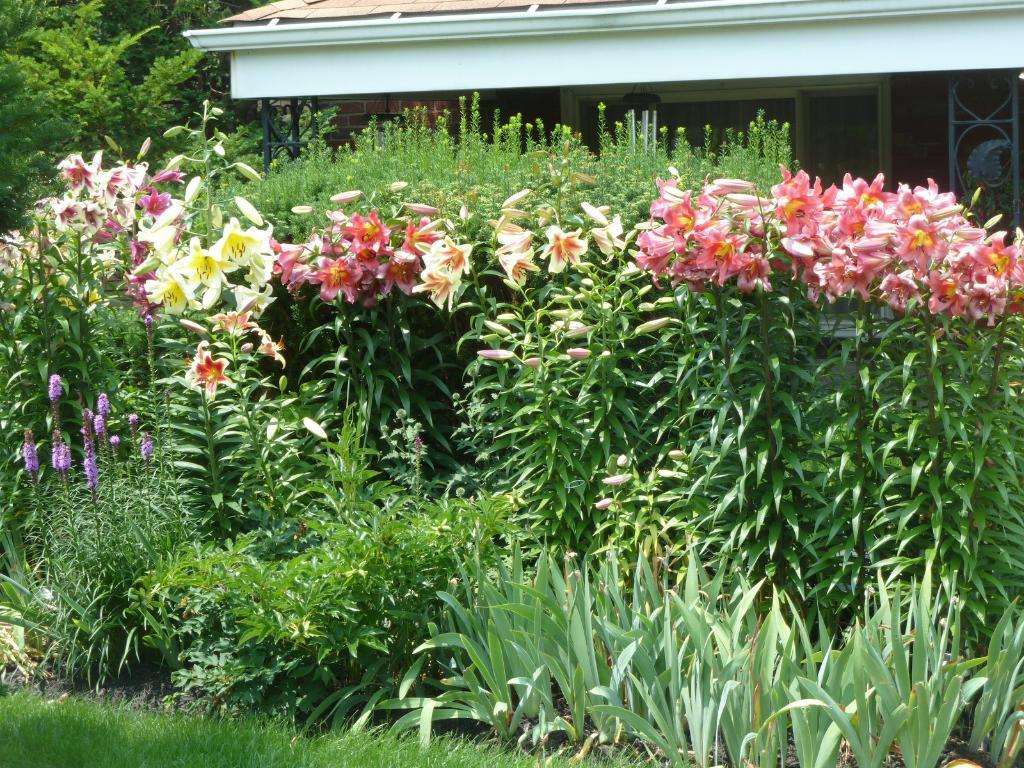What type of structure is visible in the image? There is a house in the image. What type of vegetation can be seen in the image? There are trees and plants in the image. What is growing on the trees in the image? There are flowers on the trees in the image. What covers the ground in the image? Grass is present on the ground in the image. Can you hear the bell ringing in the image? There is no bell present in the image, so it cannot be heard ringing. 